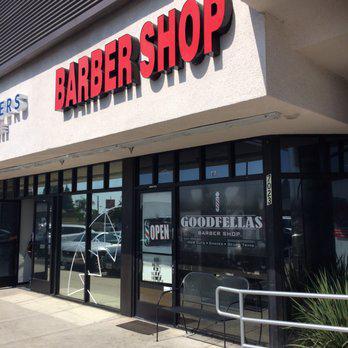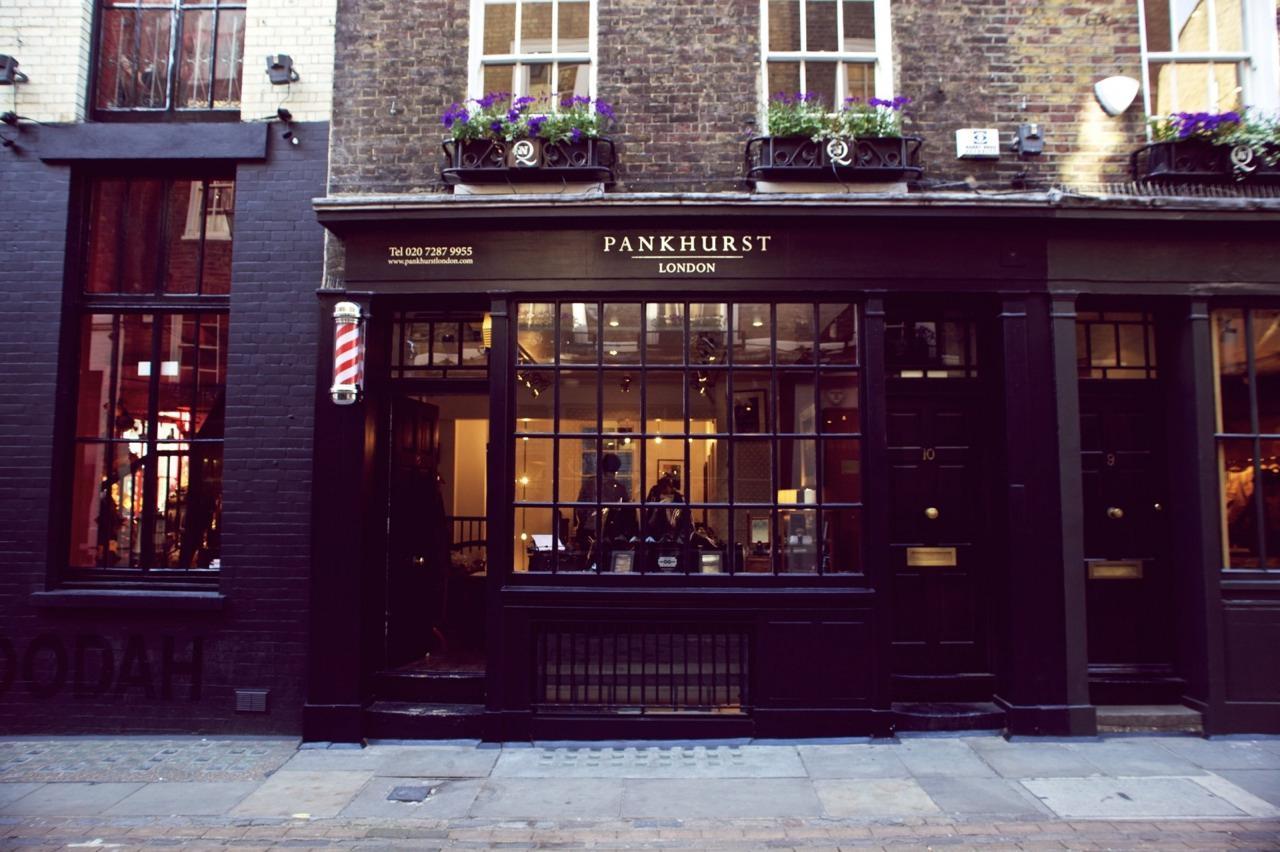The first image is the image on the left, the second image is the image on the right. Given the left and right images, does the statement "There is at least one barber pole in the image on the left." hold true? Answer yes or no. No. 